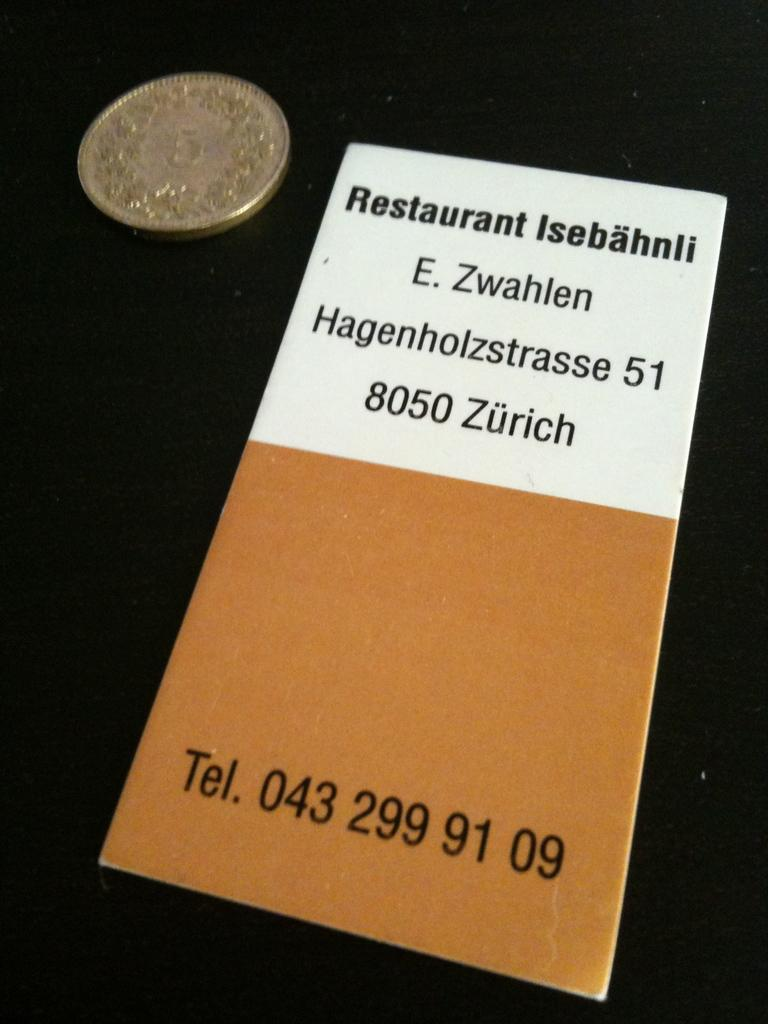<image>
Share a concise interpretation of the image provided. A restaurant menu with the phone number 043 299 91 09 on the bottom. 